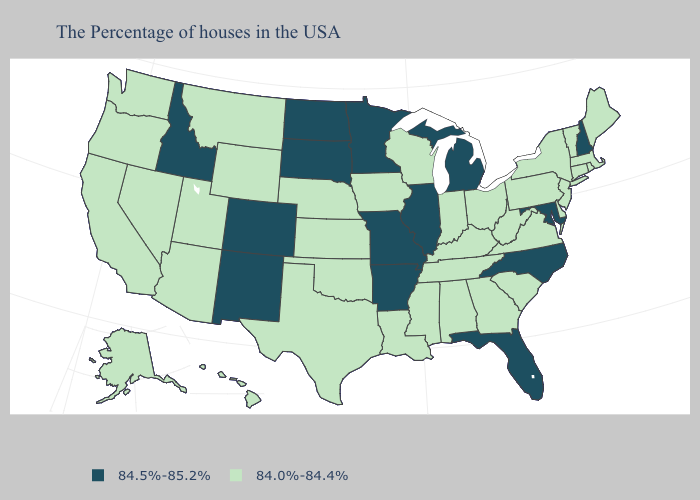Does South Dakota have a higher value than Montana?
Be succinct. Yes. Does the map have missing data?
Quick response, please. No. What is the lowest value in states that border South Dakota?
Give a very brief answer. 84.0%-84.4%. What is the value of South Dakota?
Be succinct. 84.5%-85.2%. What is the lowest value in the USA?
Give a very brief answer. 84.0%-84.4%. Is the legend a continuous bar?
Answer briefly. No. Does New Hampshire have the highest value in the Northeast?
Concise answer only. Yes. Name the states that have a value in the range 84.5%-85.2%?
Keep it brief. New Hampshire, Maryland, North Carolina, Florida, Michigan, Illinois, Missouri, Arkansas, Minnesota, South Dakota, North Dakota, Colorado, New Mexico, Idaho. What is the value of Idaho?
Concise answer only. 84.5%-85.2%. Name the states that have a value in the range 84.0%-84.4%?
Give a very brief answer. Maine, Massachusetts, Rhode Island, Vermont, Connecticut, New York, New Jersey, Delaware, Pennsylvania, Virginia, South Carolina, West Virginia, Ohio, Georgia, Kentucky, Indiana, Alabama, Tennessee, Wisconsin, Mississippi, Louisiana, Iowa, Kansas, Nebraska, Oklahoma, Texas, Wyoming, Utah, Montana, Arizona, Nevada, California, Washington, Oregon, Alaska, Hawaii. Name the states that have a value in the range 84.5%-85.2%?
Short answer required. New Hampshire, Maryland, North Carolina, Florida, Michigan, Illinois, Missouri, Arkansas, Minnesota, South Dakota, North Dakota, Colorado, New Mexico, Idaho. Name the states that have a value in the range 84.5%-85.2%?
Quick response, please. New Hampshire, Maryland, North Carolina, Florida, Michigan, Illinois, Missouri, Arkansas, Minnesota, South Dakota, North Dakota, Colorado, New Mexico, Idaho. What is the highest value in states that border Alabama?
Short answer required. 84.5%-85.2%. Among the states that border Oregon , which have the lowest value?
Be succinct. Nevada, California, Washington. What is the value of Montana?
Concise answer only. 84.0%-84.4%. 